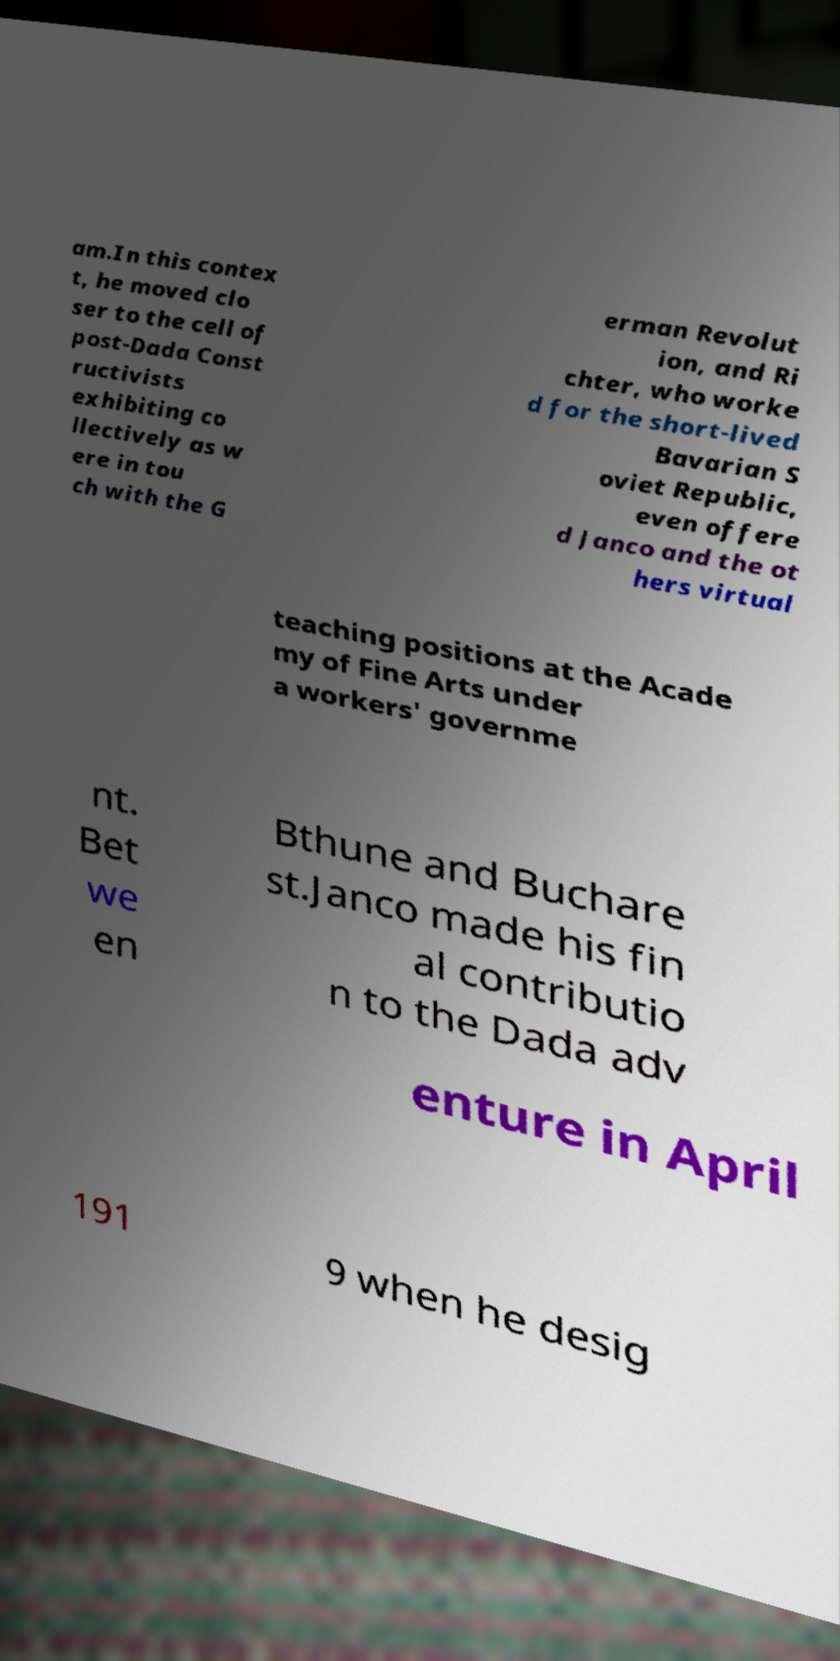Could you assist in decoding the text presented in this image and type it out clearly? am.In this contex t, he moved clo ser to the cell of post-Dada Const ructivists exhibiting co llectively as w ere in tou ch with the G erman Revolut ion, and Ri chter, who worke d for the short-lived Bavarian S oviet Republic, even offere d Janco and the ot hers virtual teaching positions at the Acade my of Fine Arts under a workers' governme nt. Bet we en Bthune and Buchare st.Janco made his fin al contributio n to the Dada adv enture in April 191 9 when he desig 